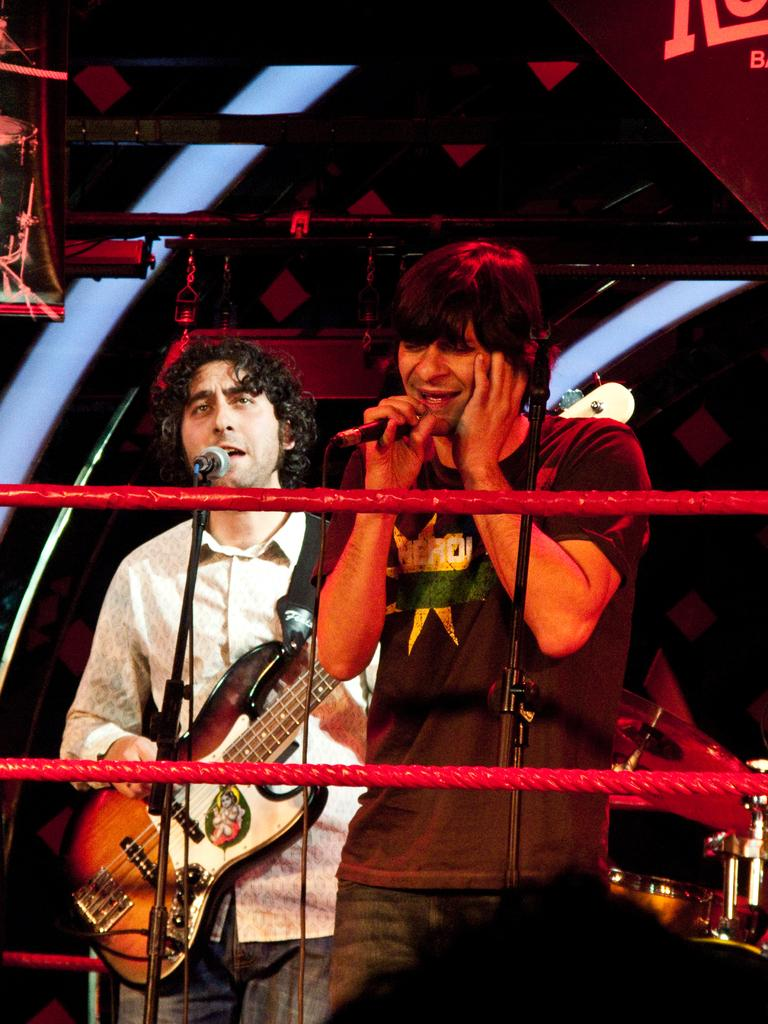How many people are in the image? There are two persons in the image. What are the two persons doing in the image? The two persons are standing in front of a microphone. What is one of the persons doing while standing in front of the microphone? One person is signing. What else is the person who is signing doing? The person who is signing is also playing a guitar. What time of day is it in the image, and what color is the blood on the table? The provided facts do not mention the time of day or any blood on a table, so we cannot answer these questions based on the image. 